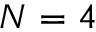Convert formula to latex. <formula><loc_0><loc_0><loc_500><loc_500>N = 4</formula> 